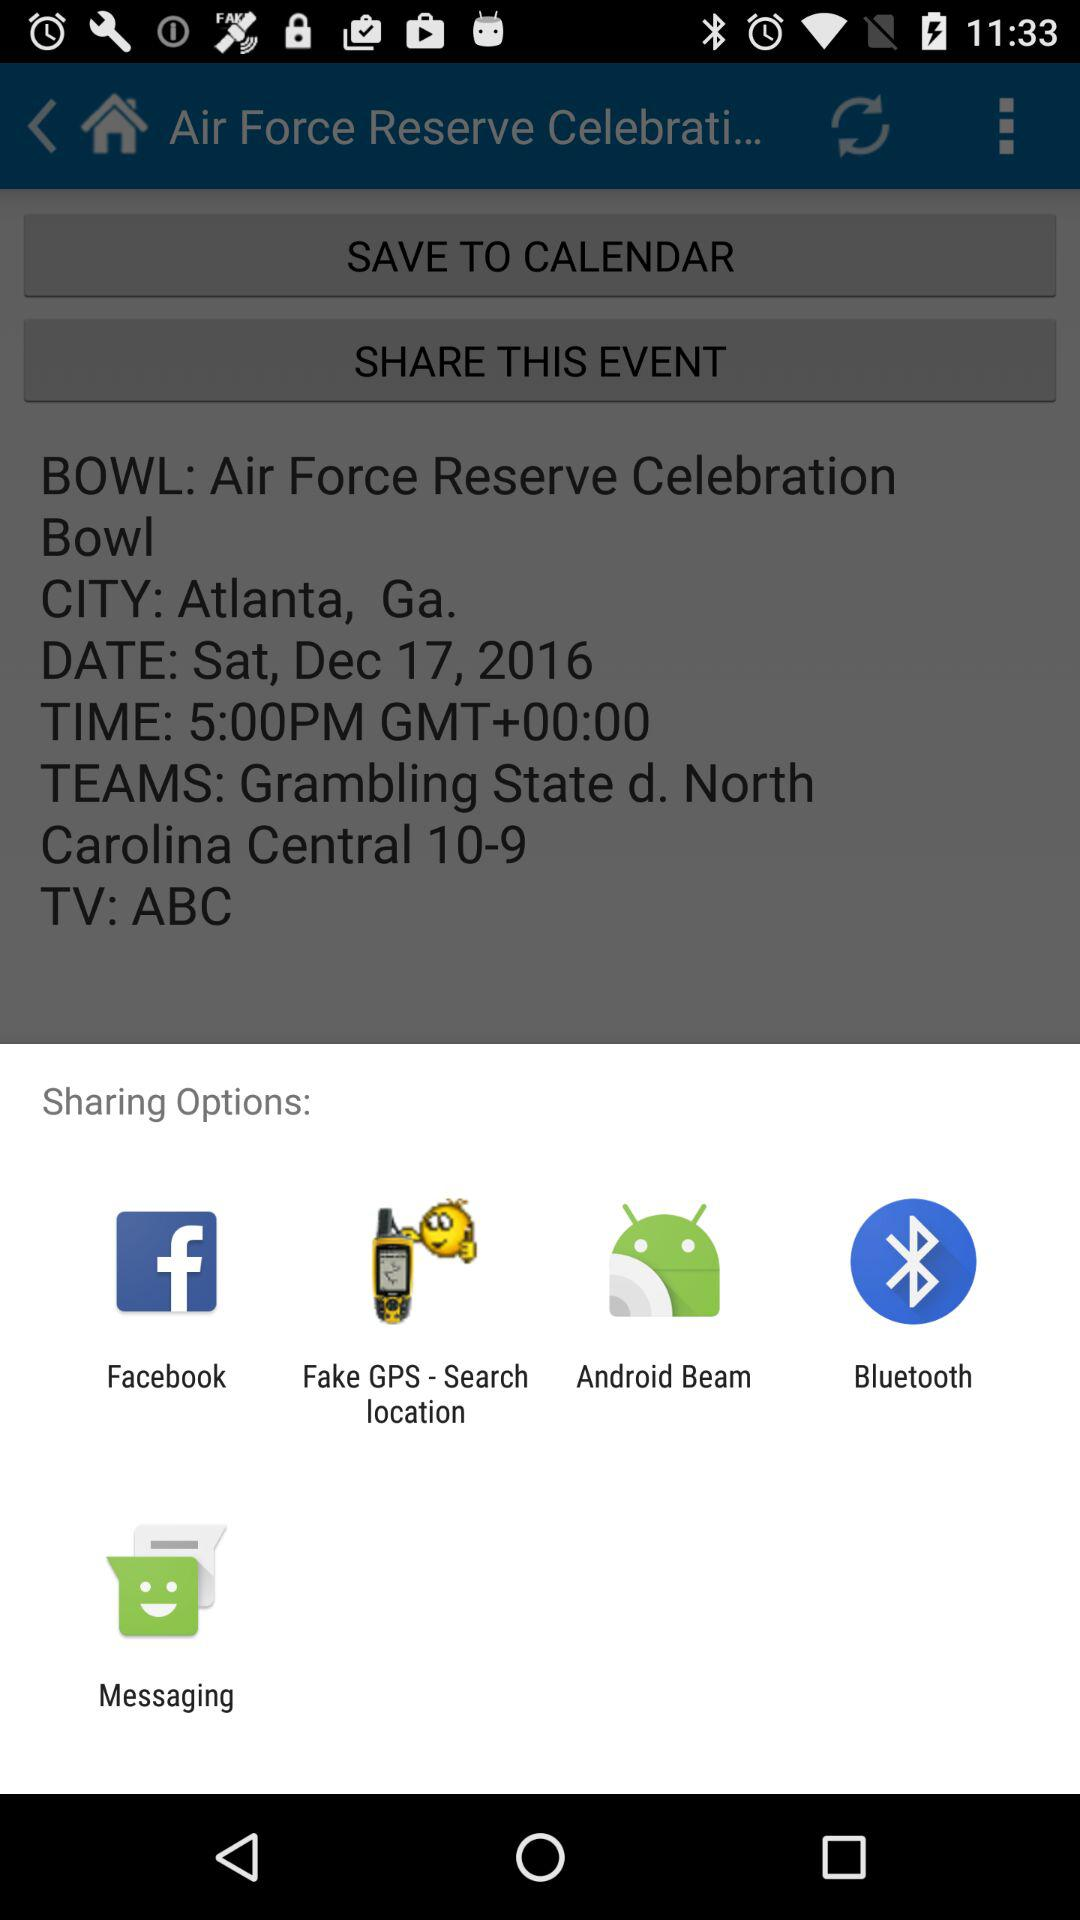In which city is the event happening? The event is happening in Atlanta, Georgia. 